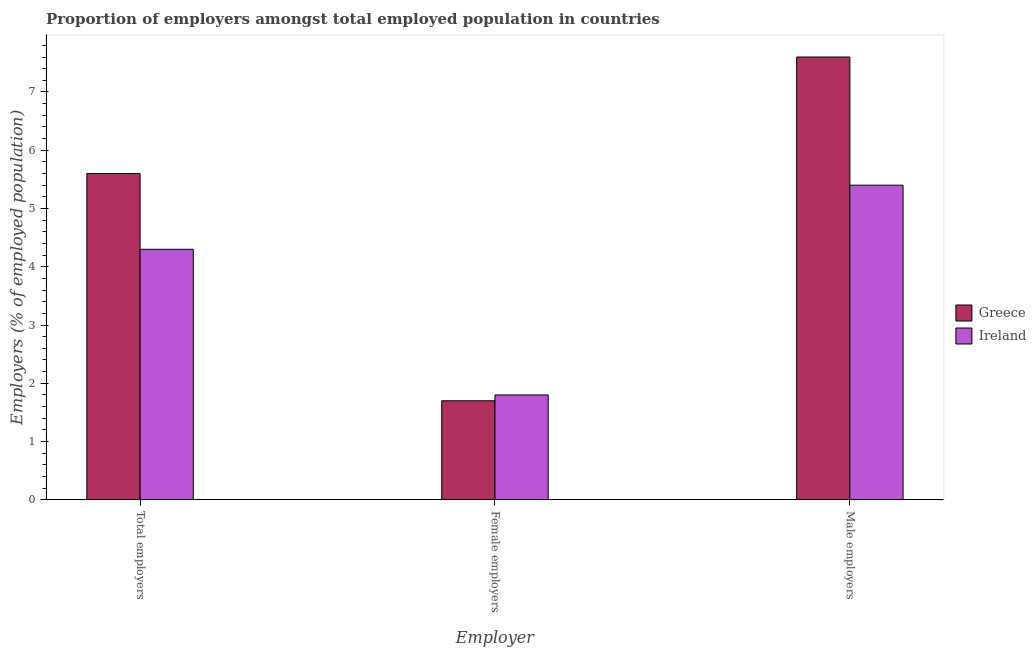How many groups of bars are there?
Make the answer very short. 3. Are the number of bars per tick equal to the number of legend labels?
Offer a very short reply. Yes. Are the number of bars on each tick of the X-axis equal?
Your answer should be very brief. Yes. What is the label of the 3rd group of bars from the left?
Offer a terse response. Male employers. What is the percentage of total employers in Greece?
Give a very brief answer. 5.6. Across all countries, what is the maximum percentage of total employers?
Offer a terse response. 5.6. Across all countries, what is the minimum percentage of male employers?
Ensure brevity in your answer.  5.4. In which country was the percentage of female employers maximum?
Give a very brief answer. Ireland. What is the total percentage of female employers in the graph?
Ensure brevity in your answer.  3.5. What is the difference between the percentage of total employers in Ireland and that in Greece?
Give a very brief answer. -1.3. What is the difference between the percentage of total employers in Greece and the percentage of male employers in Ireland?
Provide a succinct answer. 0.2. What is the average percentage of total employers per country?
Your answer should be very brief. 4.95. What is the difference between the percentage of female employers and percentage of male employers in Ireland?
Your answer should be compact. -3.6. What is the ratio of the percentage of total employers in Ireland to that in Greece?
Your answer should be very brief. 0.77. Is the difference between the percentage of female employers in Greece and Ireland greater than the difference between the percentage of male employers in Greece and Ireland?
Offer a very short reply. No. What is the difference between the highest and the second highest percentage of total employers?
Make the answer very short. 1.3. What is the difference between the highest and the lowest percentage of female employers?
Give a very brief answer. 0.1. In how many countries, is the percentage of male employers greater than the average percentage of male employers taken over all countries?
Make the answer very short. 1. What does the 2nd bar from the left in Male employers represents?
Keep it short and to the point. Ireland. What does the 1st bar from the right in Female employers represents?
Your answer should be very brief. Ireland. Are all the bars in the graph horizontal?
Make the answer very short. No. How many countries are there in the graph?
Offer a terse response. 2. What is the difference between two consecutive major ticks on the Y-axis?
Provide a short and direct response. 1. Are the values on the major ticks of Y-axis written in scientific E-notation?
Ensure brevity in your answer.  No. Does the graph contain any zero values?
Provide a short and direct response. No. Where does the legend appear in the graph?
Provide a short and direct response. Center right. How are the legend labels stacked?
Ensure brevity in your answer.  Vertical. What is the title of the graph?
Provide a succinct answer. Proportion of employers amongst total employed population in countries. Does "Iran" appear as one of the legend labels in the graph?
Offer a very short reply. No. What is the label or title of the X-axis?
Make the answer very short. Employer. What is the label or title of the Y-axis?
Provide a succinct answer. Employers (% of employed population). What is the Employers (% of employed population) in Greece in Total employers?
Your response must be concise. 5.6. What is the Employers (% of employed population) in Ireland in Total employers?
Keep it short and to the point. 4.3. What is the Employers (% of employed population) of Greece in Female employers?
Offer a terse response. 1.7. What is the Employers (% of employed population) in Ireland in Female employers?
Your answer should be compact. 1.8. What is the Employers (% of employed population) in Greece in Male employers?
Provide a succinct answer. 7.6. What is the Employers (% of employed population) of Ireland in Male employers?
Your answer should be compact. 5.4. Across all Employer, what is the maximum Employers (% of employed population) of Greece?
Give a very brief answer. 7.6. Across all Employer, what is the maximum Employers (% of employed population) of Ireland?
Offer a very short reply. 5.4. Across all Employer, what is the minimum Employers (% of employed population) in Greece?
Your response must be concise. 1.7. Across all Employer, what is the minimum Employers (% of employed population) of Ireland?
Give a very brief answer. 1.8. What is the total Employers (% of employed population) of Ireland in the graph?
Your answer should be compact. 11.5. What is the difference between the Employers (% of employed population) in Greece in Total employers and that in Female employers?
Your response must be concise. 3.9. What is the difference between the Employers (% of employed population) in Ireland in Total employers and that in Female employers?
Offer a terse response. 2.5. What is the difference between the Employers (% of employed population) in Greece in Total employers and the Employers (% of employed population) in Ireland in Female employers?
Your answer should be compact. 3.8. What is the difference between the Employers (% of employed population) in Greece in Total employers and the Employers (% of employed population) in Ireland in Male employers?
Your answer should be compact. 0.2. What is the difference between the Employers (% of employed population) in Greece in Female employers and the Employers (% of employed population) in Ireland in Male employers?
Offer a terse response. -3.7. What is the average Employers (% of employed population) in Greece per Employer?
Give a very brief answer. 4.97. What is the average Employers (% of employed population) of Ireland per Employer?
Your response must be concise. 3.83. What is the difference between the Employers (% of employed population) in Greece and Employers (% of employed population) in Ireland in Total employers?
Your answer should be compact. 1.3. What is the difference between the Employers (% of employed population) in Greece and Employers (% of employed population) in Ireland in Female employers?
Make the answer very short. -0.1. What is the ratio of the Employers (% of employed population) in Greece in Total employers to that in Female employers?
Offer a very short reply. 3.29. What is the ratio of the Employers (% of employed population) in Ireland in Total employers to that in Female employers?
Offer a terse response. 2.39. What is the ratio of the Employers (% of employed population) of Greece in Total employers to that in Male employers?
Provide a succinct answer. 0.74. What is the ratio of the Employers (% of employed population) of Ireland in Total employers to that in Male employers?
Make the answer very short. 0.8. What is the ratio of the Employers (% of employed population) of Greece in Female employers to that in Male employers?
Make the answer very short. 0.22. What is the difference between the highest and the second highest Employers (% of employed population) of Greece?
Your answer should be very brief. 2. What is the difference between the highest and the lowest Employers (% of employed population) in Ireland?
Ensure brevity in your answer.  3.6. 